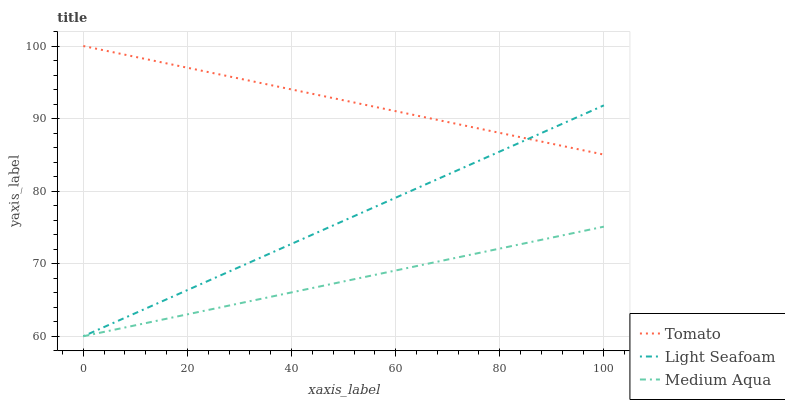Does Medium Aqua have the minimum area under the curve?
Answer yes or no. Yes. Does Tomato have the maximum area under the curve?
Answer yes or no. Yes. Does Light Seafoam have the minimum area under the curve?
Answer yes or no. No. Does Light Seafoam have the maximum area under the curve?
Answer yes or no. No. Is Light Seafoam the smoothest?
Answer yes or no. Yes. Is Tomato the roughest?
Answer yes or no. Yes. Is Medium Aqua the smoothest?
Answer yes or no. No. Is Medium Aqua the roughest?
Answer yes or no. No. Does Light Seafoam have the highest value?
Answer yes or no. No. Is Medium Aqua less than Tomato?
Answer yes or no. Yes. Is Tomato greater than Medium Aqua?
Answer yes or no. Yes. Does Medium Aqua intersect Tomato?
Answer yes or no. No. 